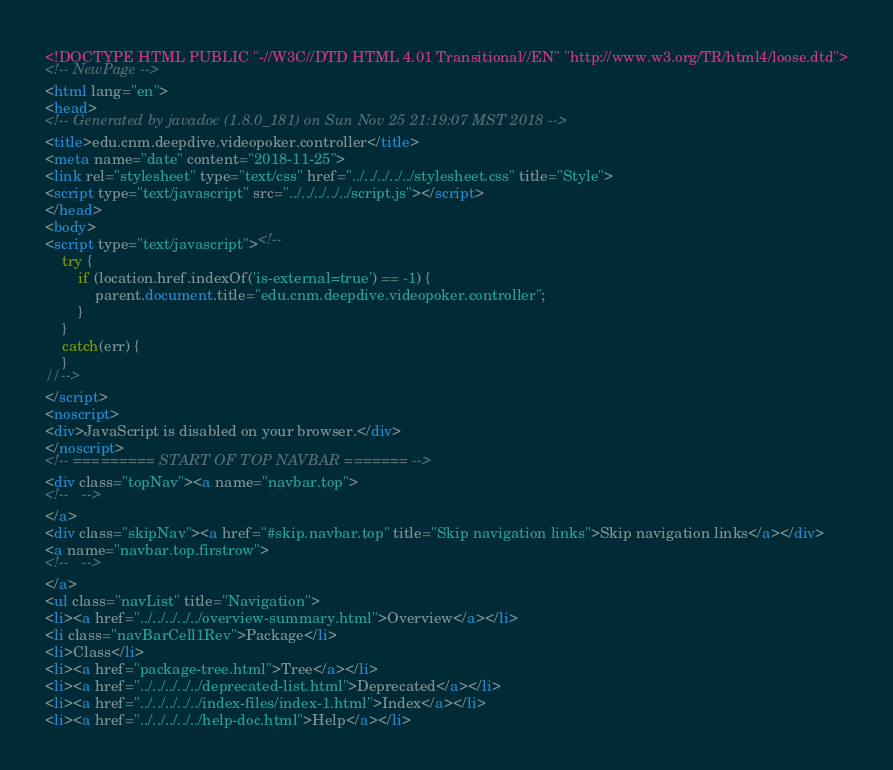Convert code to text. <code><loc_0><loc_0><loc_500><loc_500><_HTML_><!DOCTYPE HTML PUBLIC "-//W3C//DTD HTML 4.01 Transitional//EN" "http://www.w3.org/TR/html4/loose.dtd">
<!-- NewPage -->
<html lang="en">
<head>
<!-- Generated by javadoc (1.8.0_181) on Sun Nov 25 21:19:07 MST 2018 -->
<title>edu.cnm.deepdive.videopoker.controller</title>
<meta name="date" content="2018-11-25">
<link rel="stylesheet" type="text/css" href="../../../../../stylesheet.css" title="Style">
<script type="text/javascript" src="../../../../../script.js"></script>
</head>
<body>
<script type="text/javascript"><!--
    try {
        if (location.href.indexOf('is-external=true') == -1) {
            parent.document.title="edu.cnm.deepdive.videopoker.controller";
        }
    }
    catch(err) {
    }
//-->
</script>
<noscript>
<div>JavaScript is disabled on your browser.</div>
</noscript>
<!-- ========= START OF TOP NAVBAR ======= -->
<div class="topNav"><a name="navbar.top">
<!--   -->
</a>
<div class="skipNav"><a href="#skip.navbar.top" title="Skip navigation links">Skip navigation links</a></div>
<a name="navbar.top.firstrow">
<!--   -->
</a>
<ul class="navList" title="Navigation">
<li><a href="../../../../../overview-summary.html">Overview</a></li>
<li class="navBarCell1Rev">Package</li>
<li>Class</li>
<li><a href="package-tree.html">Tree</a></li>
<li><a href="../../../../../deprecated-list.html">Deprecated</a></li>
<li><a href="../../../../../index-files/index-1.html">Index</a></li>
<li><a href="../../../../../help-doc.html">Help</a></li></code> 